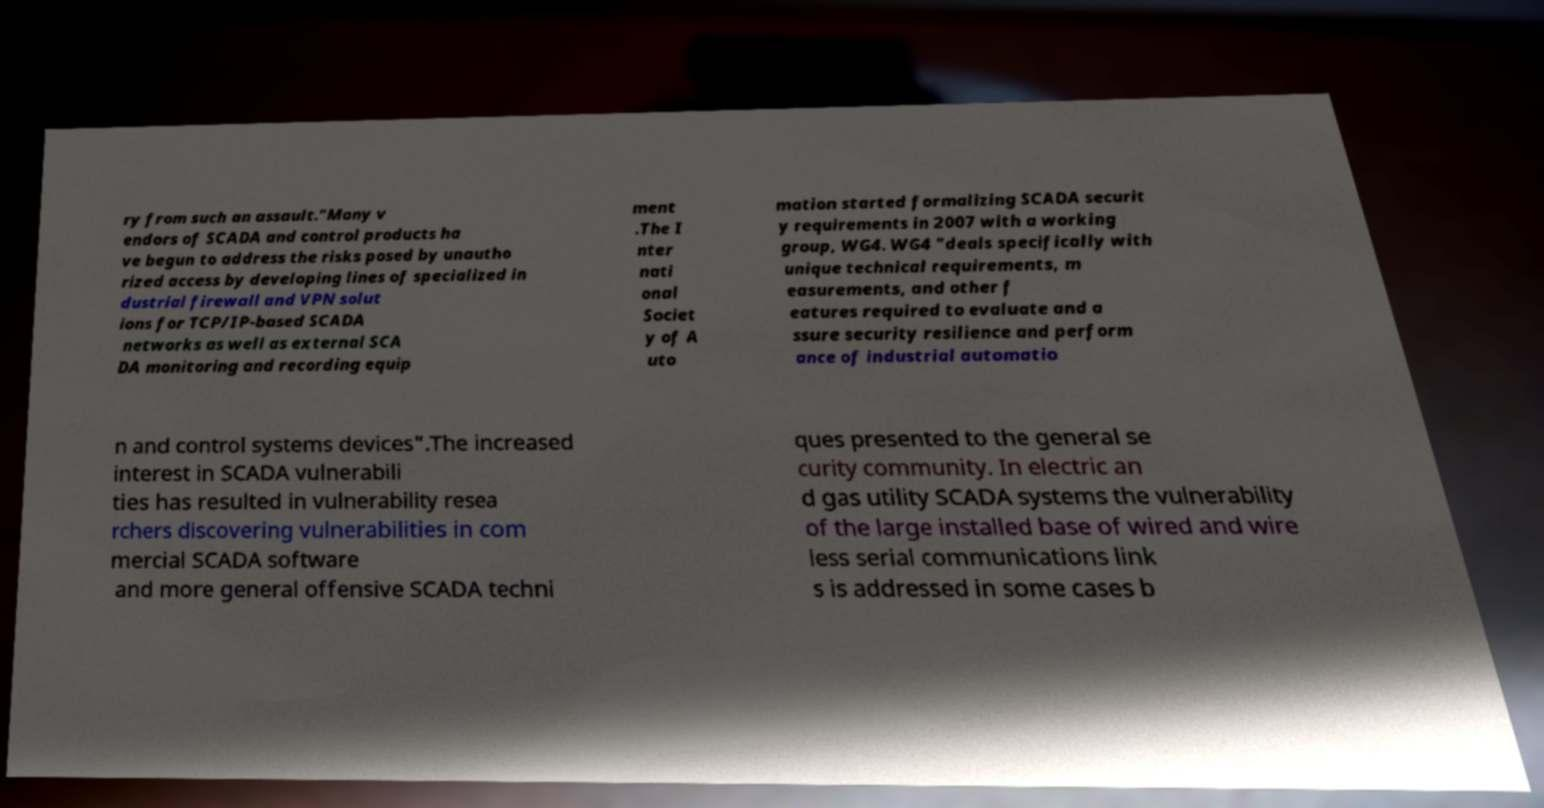What messages or text are displayed in this image? I need them in a readable, typed format. ry from such an assault."Many v endors of SCADA and control products ha ve begun to address the risks posed by unautho rized access by developing lines of specialized in dustrial firewall and VPN solut ions for TCP/IP-based SCADA networks as well as external SCA DA monitoring and recording equip ment .The I nter nati onal Societ y of A uto mation started formalizing SCADA securit y requirements in 2007 with a working group, WG4. WG4 "deals specifically with unique technical requirements, m easurements, and other f eatures required to evaluate and a ssure security resilience and perform ance of industrial automatio n and control systems devices".The increased interest in SCADA vulnerabili ties has resulted in vulnerability resea rchers discovering vulnerabilities in com mercial SCADA software and more general offensive SCADA techni ques presented to the general se curity community. In electric an d gas utility SCADA systems the vulnerability of the large installed base of wired and wire less serial communications link s is addressed in some cases b 